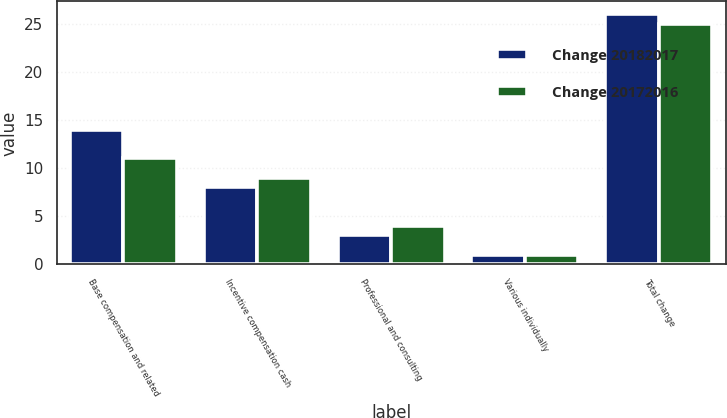Convert chart. <chart><loc_0><loc_0><loc_500><loc_500><stacked_bar_chart><ecel><fcel>Base compensation and related<fcel>Incentive compensation cash<fcel>Professional and consulting<fcel>Various individually<fcel>Total change<nl><fcel>Change 20182017<fcel>14<fcel>8<fcel>3<fcel>1<fcel>26<nl><fcel>Change 20172016<fcel>11<fcel>9<fcel>4<fcel>1<fcel>25<nl></chart> 